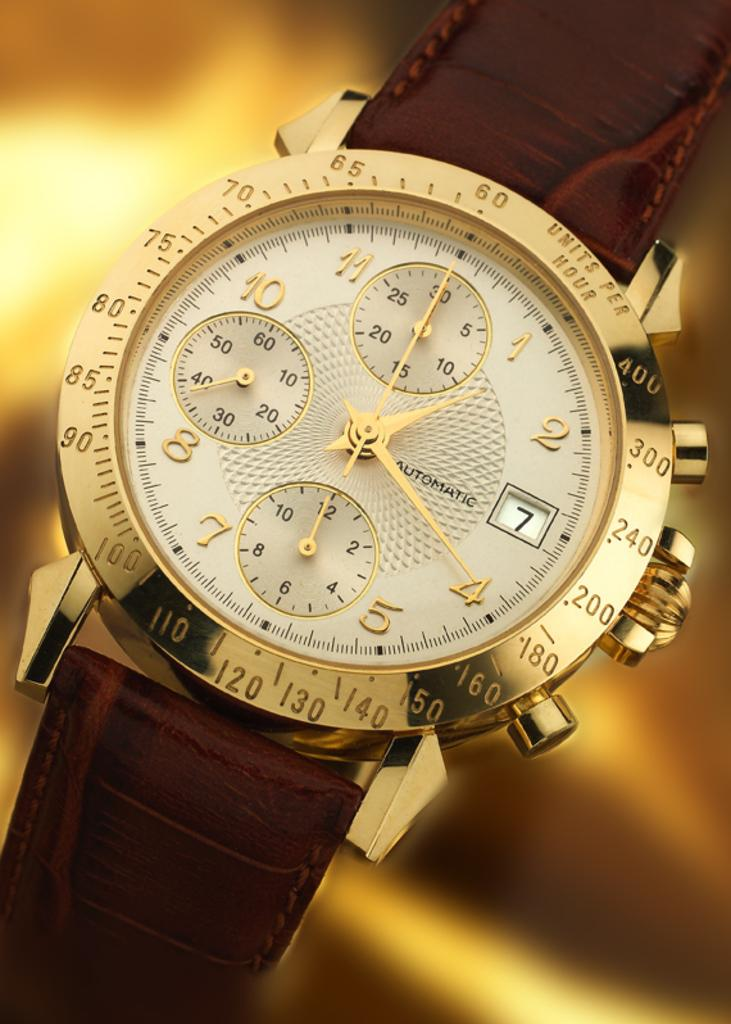<image>
Relay a brief, clear account of the picture shown. Watch that says Automatic Units per hour and has the date with the 7th. 